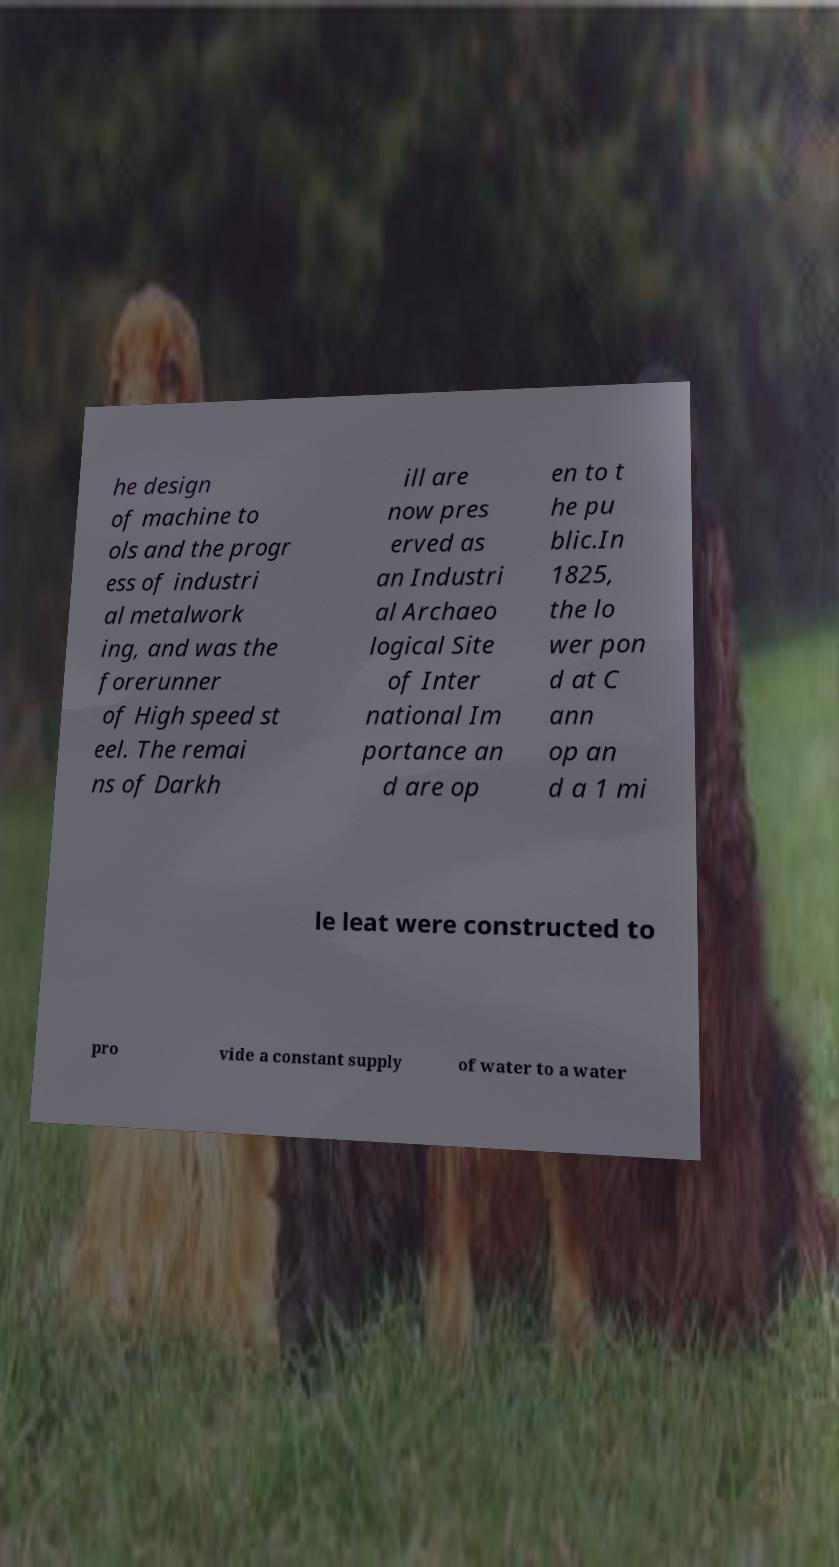What messages or text are displayed in this image? I need them in a readable, typed format. he design of machine to ols and the progr ess of industri al metalwork ing, and was the forerunner of High speed st eel. The remai ns of Darkh ill are now pres erved as an Industri al Archaeo logical Site of Inter national Im portance an d are op en to t he pu blic.In 1825, the lo wer pon d at C ann op an d a 1 mi le leat were constructed to pro vide a constant supply of water to a water 